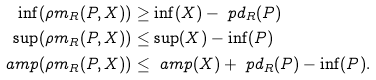Convert formula to latex. <formula><loc_0><loc_0><loc_500><loc_500>\inf ( \rho m _ { R } ( P , X ) ) & \geq \inf ( X ) - \ p d _ { R } ( P ) \\ \sup ( \rho m _ { R } ( P , X ) ) & \leq \sup ( X ) - \inf ( P ) \\ \ a m p ( \rho m _ { R } ( P , X ) ) & \leq \ a m p ( X ) + \ p d _ { R } ( P ) - \inf ( P ) .</formula> 